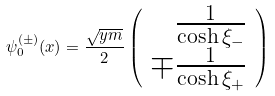<formula> <loc_0><loc_0><loc_500><loc_500>\psi _ { 0 } ^ { ( \pm ) } ( x ) = \frac { \sqrt { y m } } { 2 } \left ( \begin{array} { r } { { \frac { 1 } { \cosh \xi _ { - } } } } \\ { { \mp \frac { 1 } { \cosh \xi _ { + } } } } \end{array} \right )</formula> 